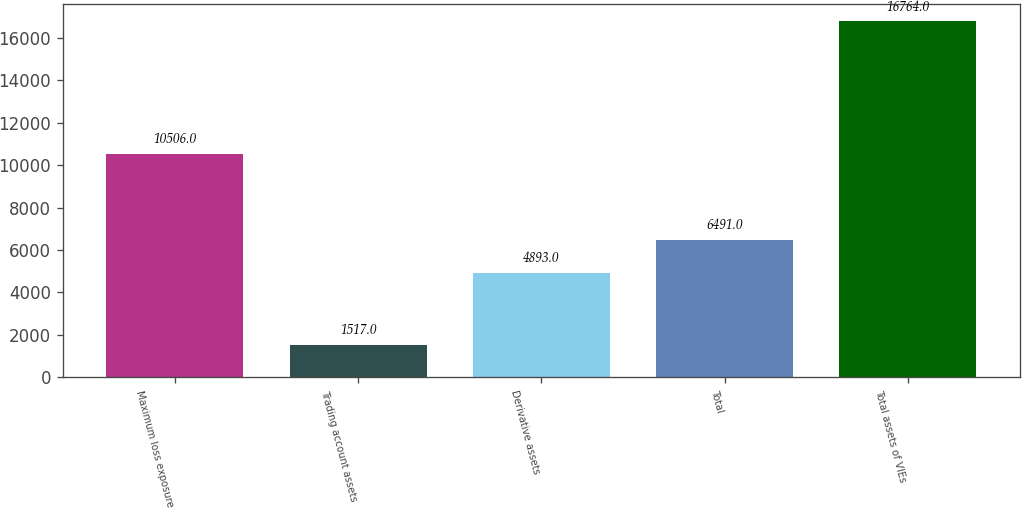<chart> <loc_0><loc_0><loc_500><loc_500><bar_chart><fcel>Maximum loss exposure<fcel>Trading account assets<fcel>Derivative assets<fcel>Total<fcel>Total assets of VIEs<nl><fcel>10506<fcel>1517<fcel>4893<fcel>6491<fcel>16764<nl></chart> 